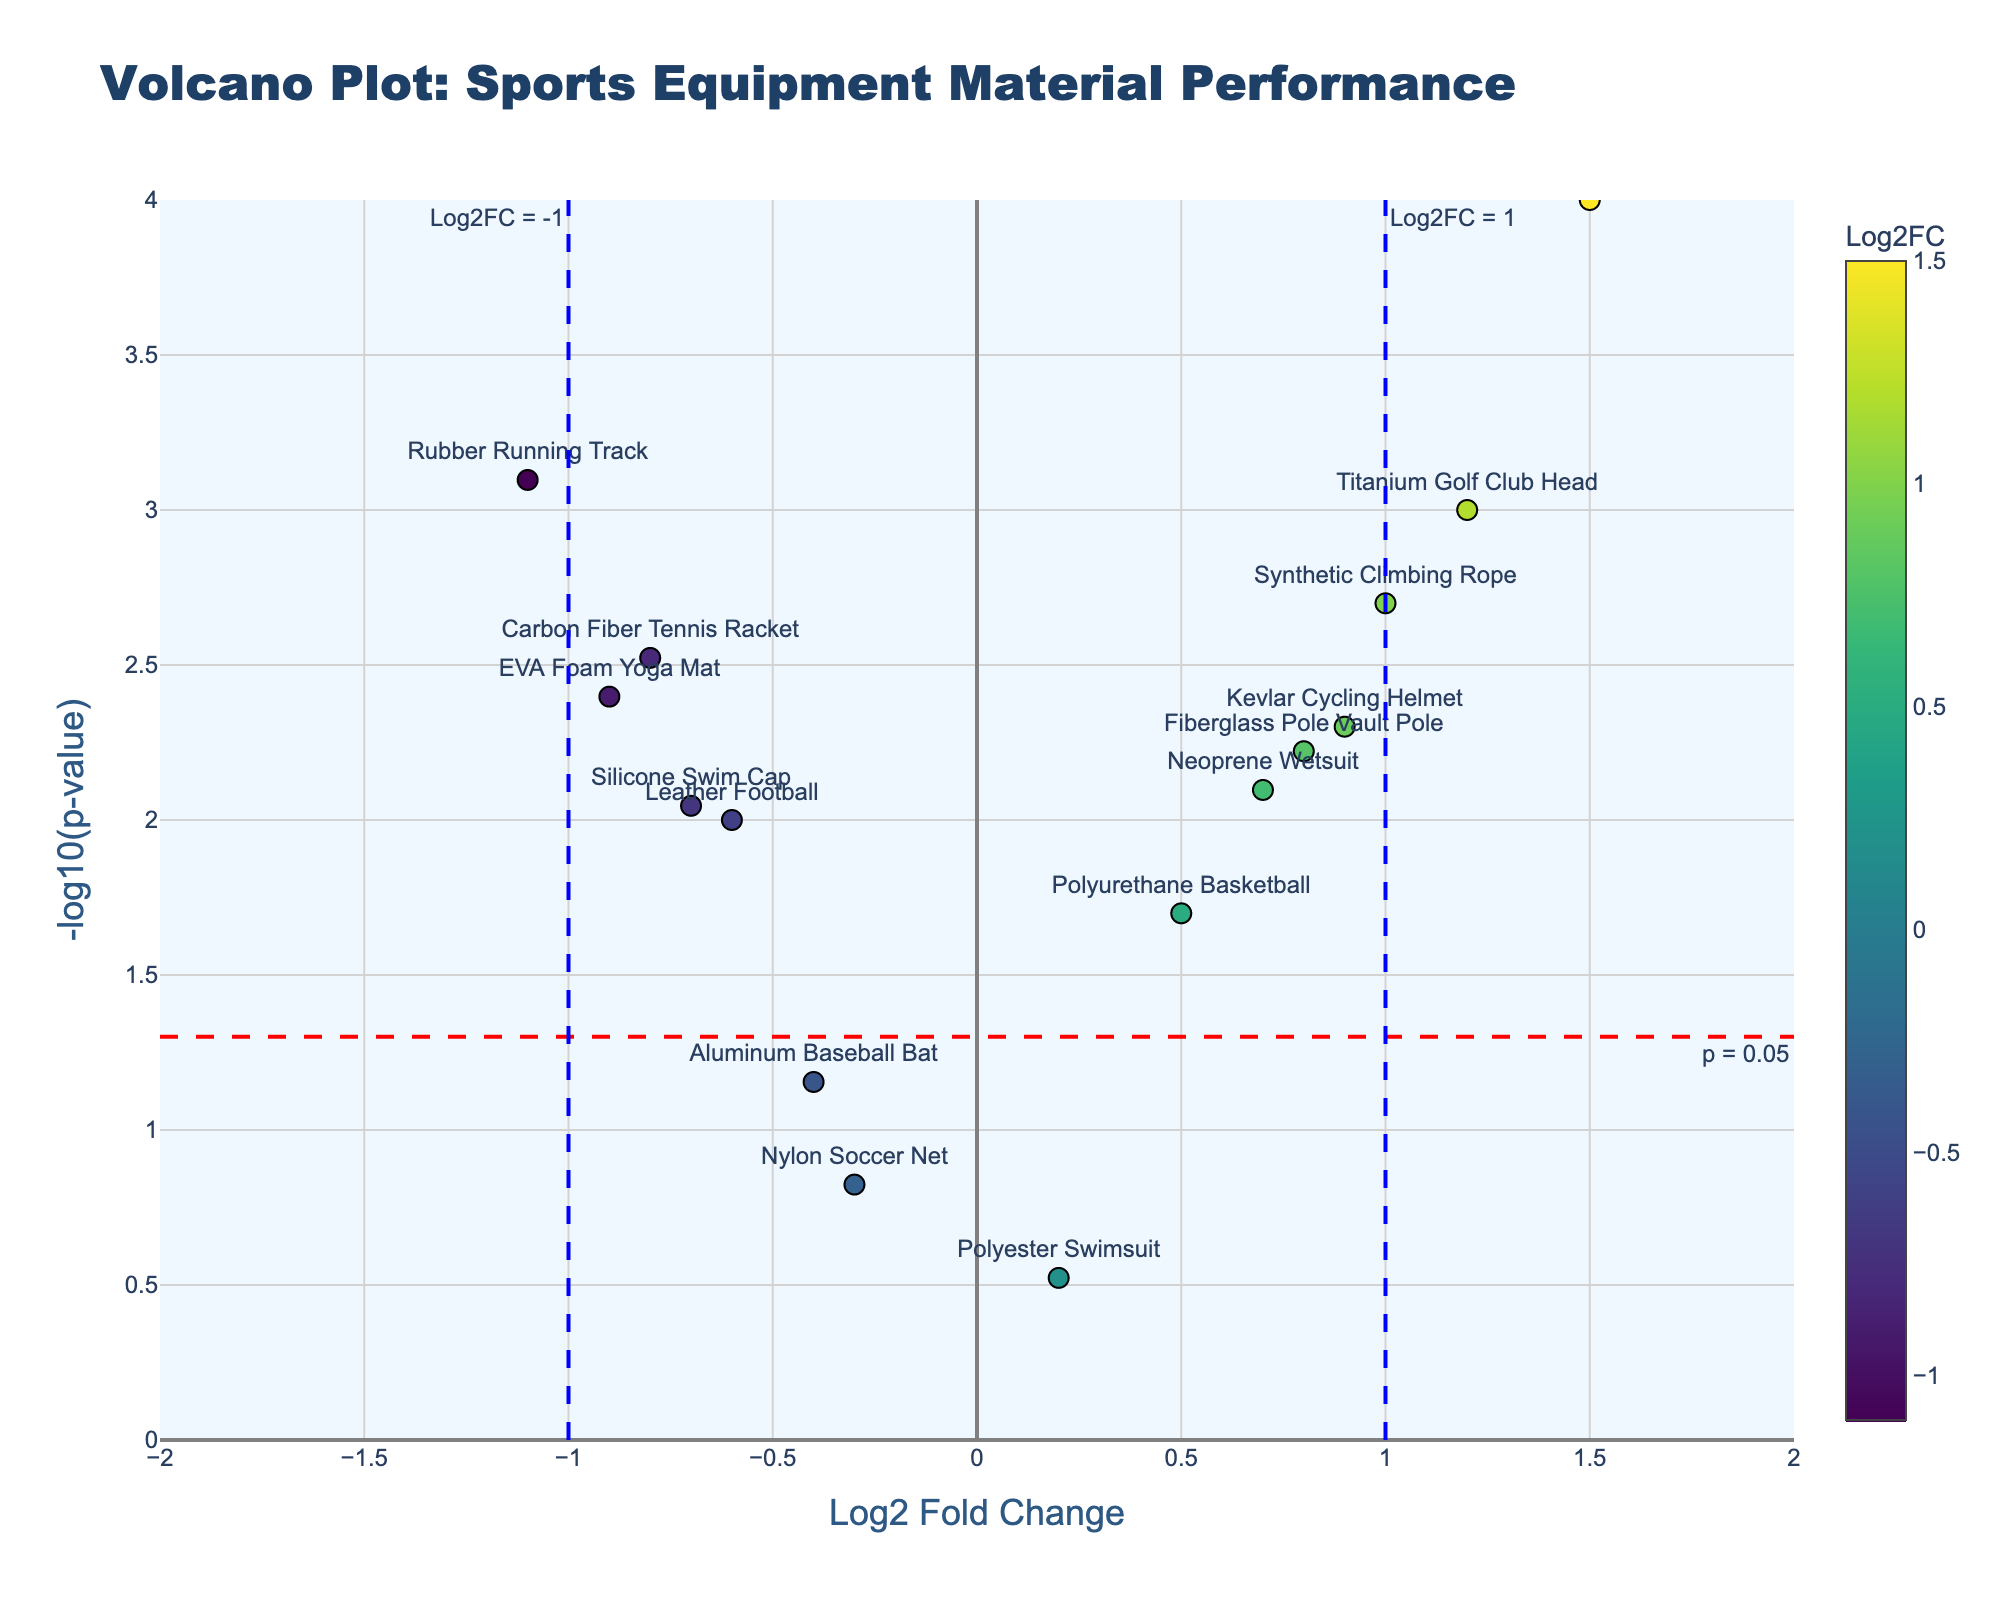Is any material above the significance threshold for P-value? To determine if any material is above the significance threshold for P-value, check if any points are above the horizontal dashed red line at -log10(0.05). The materials "Carbon Fiber Tennis Racket", "Polyurethane Basketball", "Titanium Golf Club Head", "Kevlar Cycling Helmet", "Rubber Running Track", "Graphite Ski", "Neoprene Wetsuit", "Leather Football", "Synthetic Climbing Rope", "EVA Foam Yoga Mat", "Fiberglass Pole Vault Pole", and "Silicone Swim Cap" are above this line.
Answer: Yes Which material has the highest -log10(P-value)? To find the material with the highest -log10(P-value), look at the highest point on the y-axis. The "Graphite Ski" is the highest point, therefore it has the highest -log10(P-value).
Answer: Graphite Ski What is the Log2FC value for "Rubber Running Track"? Locate the "Rubber Running Track" label on the plot, and check its position on the x-axis to find its Log2FC value, which is -1.1.
Answer: -1.1 Compare the Log2FC values of "Kevlar Cycling Helmet" and "Titanium Golf Club Head". Which one is higher? "Kevlar Cycling Helmet" has a Log2FC of 0.9, and "Titanium Golf Club Head" has a Log2FC of 1.2. Since 1.2 is higher than 0.9, "Titanium Golf Club Head" has a higher Log2FC.
Answer: Titanium Golf Club Head How many materials have a Log2FC greater than 1? To find the number of materials with a Log2FC greater than 1, look at the points to the right of the vertical blue dashed line at Log2FC = 1. There are two materials: "Titanium Golf Club Head" and "Graphite Ski".
Answer: 2 Are there any materials with a Log2FC less than -1? To check if there are materials with a Log2FC less than -1, look for points to the left of the vertical blue dashed line at Log2FC = -1. The "Rubber Running Track" is the only material in this region.
Answer: Yes What does a Log2FC value of 0 indicate in this plot? A Log2FC value of 0 would indicate no change in performance degradation or durability under the various environmental conditions. As there are no points exactly at Log2FC = 0 in the plot, no materials exhibit no change.
Answer: No change Which material has a P-value closest to the significance threshold (0.05)? Check for the material closest to the horizontal dashed red line at -log10(0.05). The "Aluminum Baseball Bat" is closest to this line with a P-value of 0.07.
Answer: Aluminum Baseball Bat Which material has the second-highest -log10(P-value)? To determine the second-highest -log10(P-value), locate the points vertically from highest to second-highest for the y-axis value. The "Titanium Golf Club Head" is the second-highest.
Answer: Titanium Golf Club Head 